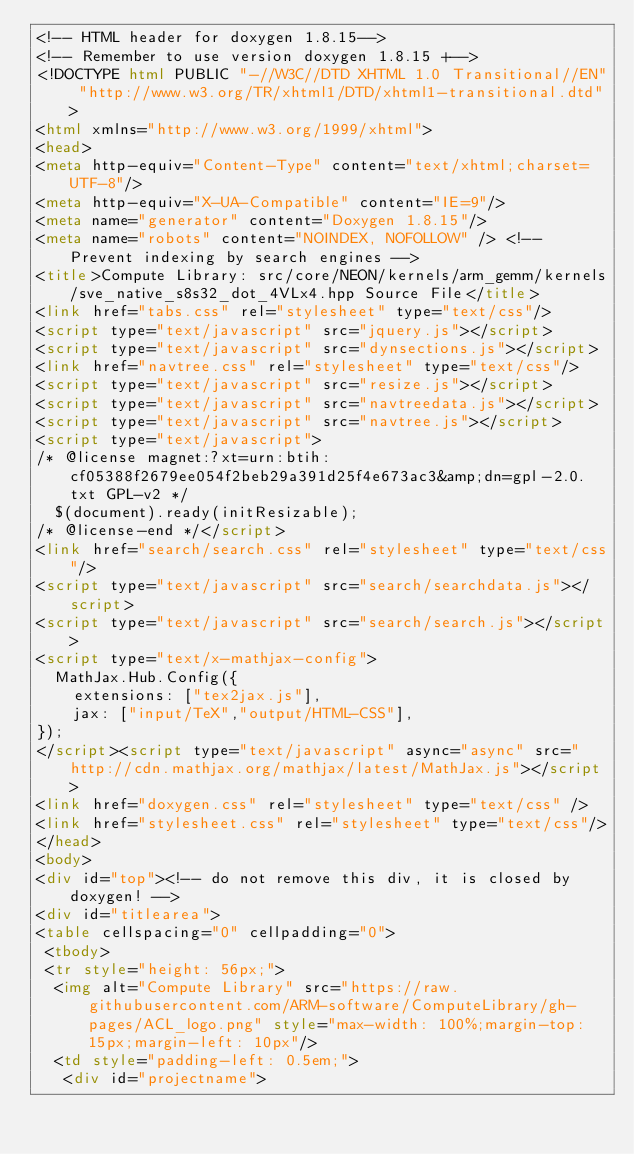<code> <loc_0><loc_0><loc_500><loc_500><_HTML_><!-- HTML header for doxygen 1.8.15-->
<!-- Remember to use version doxygen 1.8.15 +-->
<!DOCTYPE html PUBLIC "-//W3C//DTD XHTML 1.0 Transitional//EN" "http://www.w3.org/TR/xhtml1/DTD/xhtml1-transitional.dtd">
<html xmlns="http://www.w3.org/1999/xhtml">
<head>
<meta http-equiv="Content-Type" content="text/xhtml;charset=UTF-8"/>
<meta http-equiv="X-UA-Compatible" content="IE=9"/>
<meta name="generator" content="Doxygen 1.8.15"/>
<meta name="robots" content="NOINDEX, NOFOLLOW" /> <!-- Prevent indexing by search engines -->
<title>Compute Library: src/core/NEON/kernels/arm_gemm/kernels/sve_native_s8s32_dot_4VLx4.hpp Source File</title>
<link href="tabs.css" rel="stylesheet" type="text/css"/>
<script type="text/javascript" src="jquery.js"></script>
<script type="text/javascript" src="dynsections.js"></script>
<link href="navtree.css" rel="stylesheet" type="text/css"/>
<script type="text/javascript" src="resize.js"></script>
<script type="text/javascript" src="navtreedata.js"></script>
<script type="text/javascript" src="navtree.js"></script>
<script type="text/javascript">
/* @license magnet:?xt=urn:btih:cf05388f2679ee054f2beb29a391d25f4e673ac3&amp;dn=gpl-2.0.txt GPL-v2 */
  $(document).ready(initResizable);
/* @license-end */</script>
<link href="search/search.css" rel="stylesheet" type="text/css"/>
<script type="text/javascript" src="search/searchdata.js"></script>
<script type="text/javascript" src="search/search.js"></script>
<script type="text/x-mathjax-config">
  MathJax.Hub.Config({
    extensions: ["tex2jax.js"],
    jax: ["input/TeX","output/HTML-CSS"],
});
</script><script type="text/javascript" async="async" src="http://cdn.mathjax.org/mathjax/latest/MathJax.js"></script>
<link href="doxygen.css" rel="stylesheet" type="text/css" />
<link href="stylesheet.css" rel="stylesheet" type="text/css"/>
</head>
<body>
<div id="top"><!-- do not remove this div, it is closed by doxygen! -->
<div id="titlearea">
<table cellspacing="0" cellpadding="0">
 <tbody>
 <tr style="height: 56px;">
  <img alt="Compute Library" src="https://raw.githubusercontent.com/ARM-software/ComputeLibrary/gh-pages/ACL_logo.png" style="max-width: 100%;margin-top: 15px;margin-left: 10px"/>
  <td style="padding-left: 0.5em;">
   <div id="projectname"></code> 